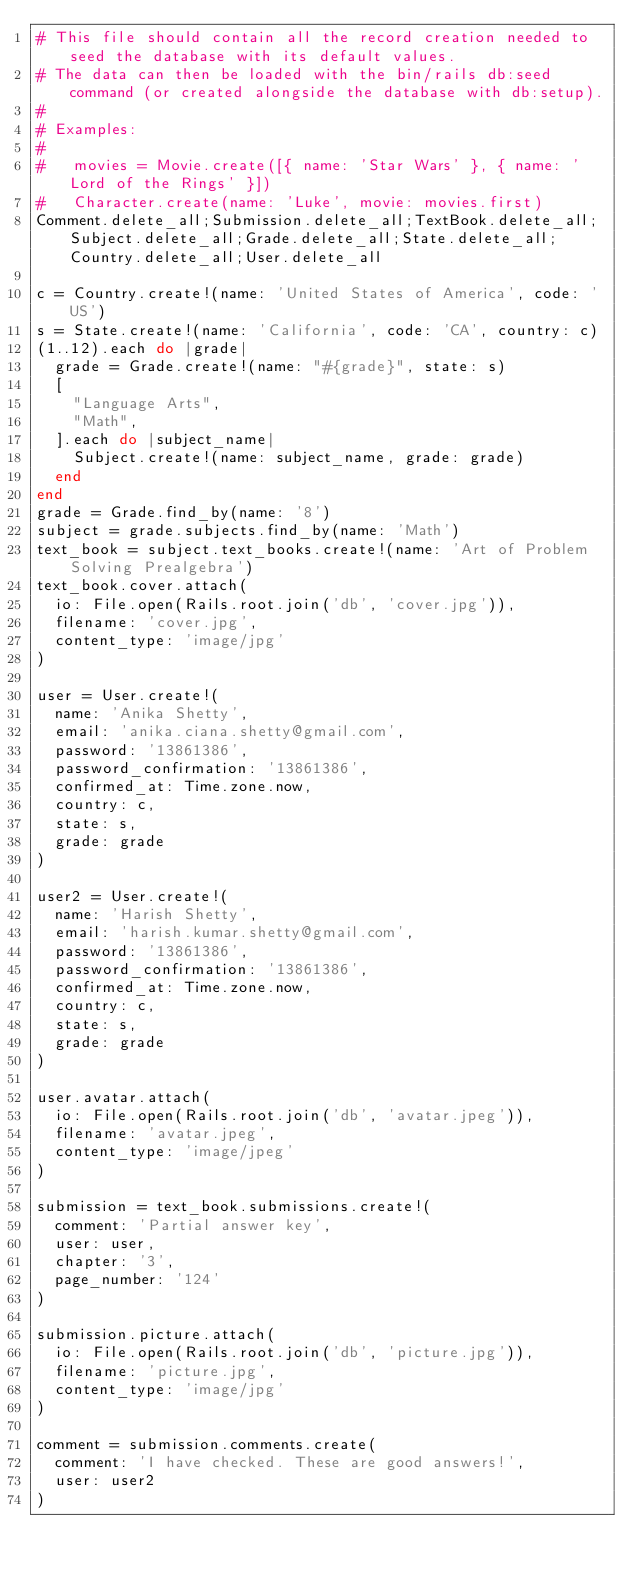<code> <loc_0><loc_0><loc_500><loc_500><_Ruby_># This file should contain all the record creation needed to seed the database with its default values.
# The data can then be loaded with the bin/rails db:seed command (or created alongside the database with db:setup).
#
# Examples:
#
#   movies = Movie.create([{ name: 'Star Wars' }, { name: 'Lord of the Rings' }])
#   Character.create(name: 'Luke', movie: movies.first)
Comment.delete_all;Submission.delete_all;TextBook.delete_all;Subject.delete_all;Grade.delete_all;State.delete_all;Country.delete_all;User.delete_all

c = Country.create!(name: 'United States of America', code: 'US')
s = State.create!(name: 'California', code: 'CA', country: c)
(1..12).each do |grade|
  grade = Grade.create!(name: "#{grade}", state: s)
  [
    "Language Arts",
    "Math",
  ].each do |subject_name|
    Subject.create!(name: subject_name, grade: grade)
  end
end
grade = Grade.find_by(name: '8')
subject = grade.subjects.find_by(name: 'Math')
text_book = subject.text_books.create!(name: 'Art of Problem Solving Prealgebra')
text_book.cover.attach(
  io: File.open(Rails.root.join('db', 'cover.jpg')),
  filename: 'cover.jpg',
  content_type: 'image/jpg'
)

user = User.create!(
  name: 'Anika Shetty',
  email: 'anika.ciana.shetty@gmail.com',
  password: '13861386',
  password_confirmation: '13861386',
  confirmed_at: Time.zone.now,
  country: c,
  state: s,
  grade: grade
)

user2 = User.create!(
  name: 'Harish Shetty',
  email: 'harish.kumar.shetty@gmail.com',
  password: '13861386',
  password_confirmation: '13861386',
  confirmed_at: Time.zone.now,
  country: c,
  state: s,
  grade: grade
)

user.avatar.attach(
  io: File.open(Rails.root.join('db', 'avatar.jpeg')),
  filename: 'avatar.jpeg',
  content_type: 'image/jpeg'
)

submission = text_book.submissions.create!(
  comment: 'Partial answer key',
  user: user,
  chapter: '3',
  page_number: '124'
)

submission.picture.attach(
  io: File.open(Rails.root.join('db', 'picture.jpg')),
  filename: 'picture.jpg',
  content_type: 'image/jpg'
)

comment = submission.comments.create(
  comment: 'I have checked. These are good answers!',
  user: user2
)
</code> 